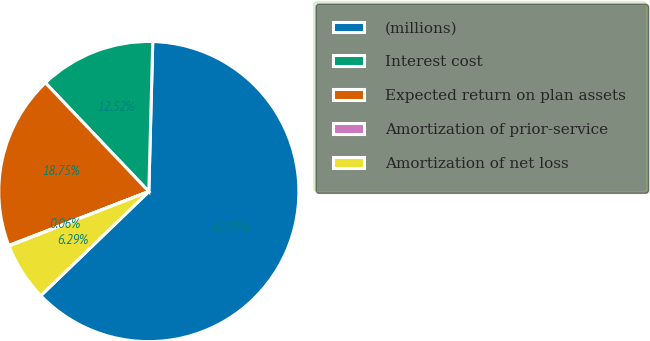Convert chart to OTSL. <chart><loc_0><loc_0><loc_500><loc_500><pie_chart><fcel>(millions)<fcel>Interest cost<fcel>Expected return on plan assets<fcel>Amortization of prior-service<fcel>Amortization of net loss<nl><fcel>62.37%<fcel>12.52%<fcel>18.75%<fcel>0.06%<fcel>6.29%<nl></chart> 